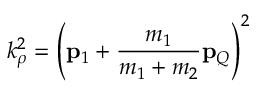Convert formula to latex. <formula><loc_0><loc_0><loc_500><loc_500>k _ { \rho } ^ { 2 } = \left ( { p } _ { 1 } + \frac { m _ { 1 } } { m _ { 1 } + m _ { 2 } } { p } _ { Q } \right ) ^ { 2 }</formula> 